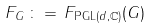<formula> <loc_0><loc_0><loc_500><loc_500>F _ { G } \, \colon = \, F _ { \text {PGL} ( d , { \mathbb { C } } ) } ( G )</formula> 